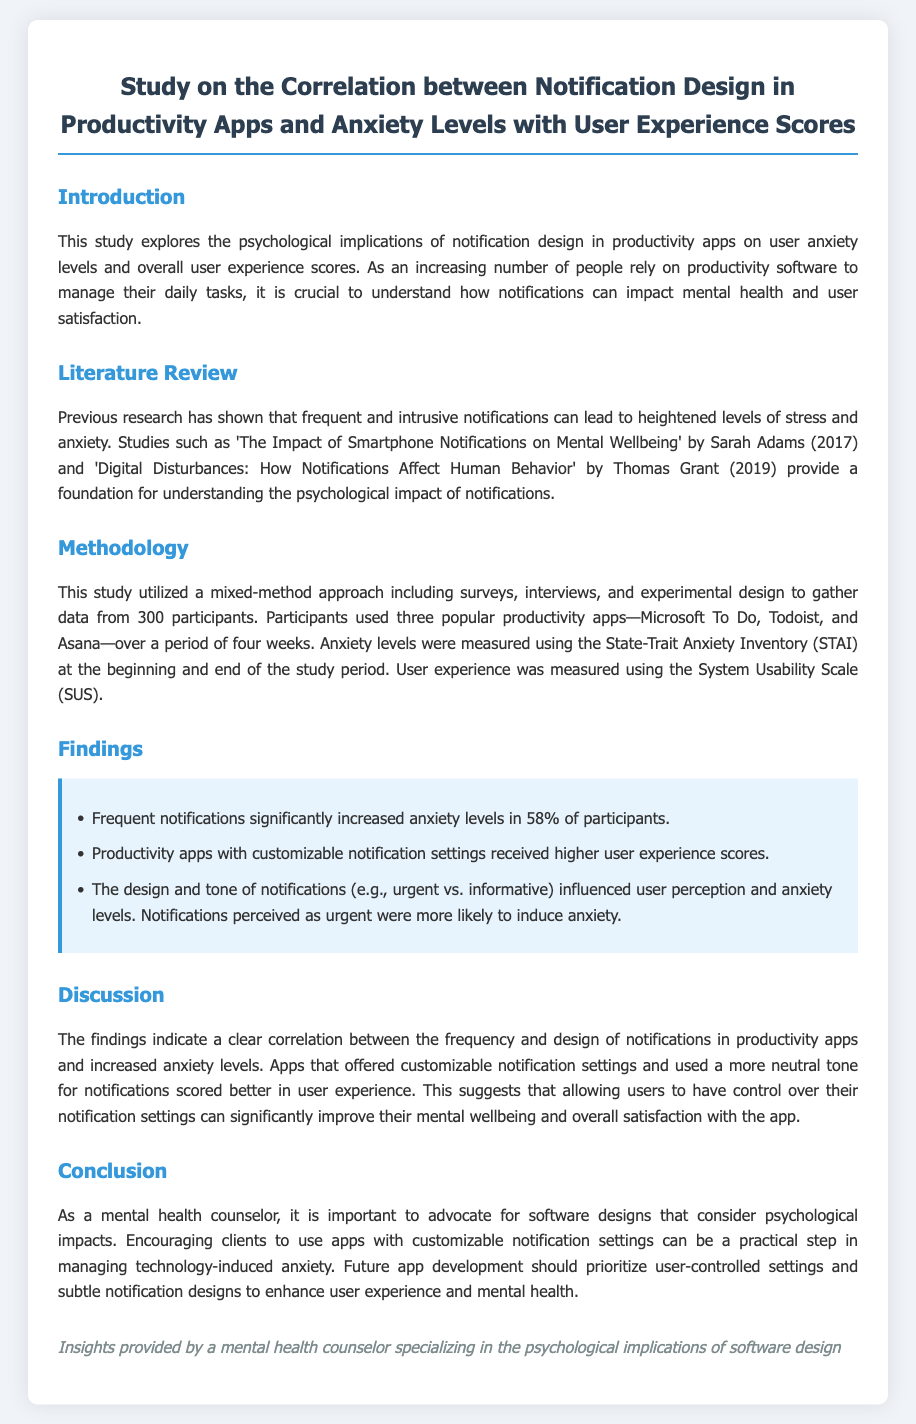What is the title of the study? The title of the study is presented at the top of the document, which focuses on the correlation between notification design and mental health.
Answer: Study on the Correlation between Notification Design in Productivity Apps and Anxiety Levels with User Experience Scores How many participants were involved in the study? The document states that data was gathered from 300 participants.
Answer: 300 What measurement tool was used to assess anxiety levels? The study utilized the State-Trait Anxiety Inventory (STAI) to evaluate anxiety levels among participants.
Answer: State-Trait Anxiety Inventory (STAI) What percentage of participants experienced increased anxiety levels due to frequent notifications? The findings highlight that 58% of the participants reported increased anxiety levels from frequent notifications.
Answer: 58% Which productivity apps were used in the study? The study involves three specific productivity apps, named in the methodology section of the document.
Answer: Microsoft To Do, Todoist, Asana What is a recommendation made in the conclusion? The conclusion advocates for encouraging clients to use apps that offer customizable notification settings to enhance mental wellbeing.
Answer: Customizable notification settings What was a significant finding regarding the tone of notifications? The findings indicated that notifications perceived as urgent were more likely to induce anxiety among users.
Answer: Urgent notifications What is the document's main focus regarding software design? The document emphasizes the importance of software design that considers psychological impacts on users.
Answer: Psychological impacts 